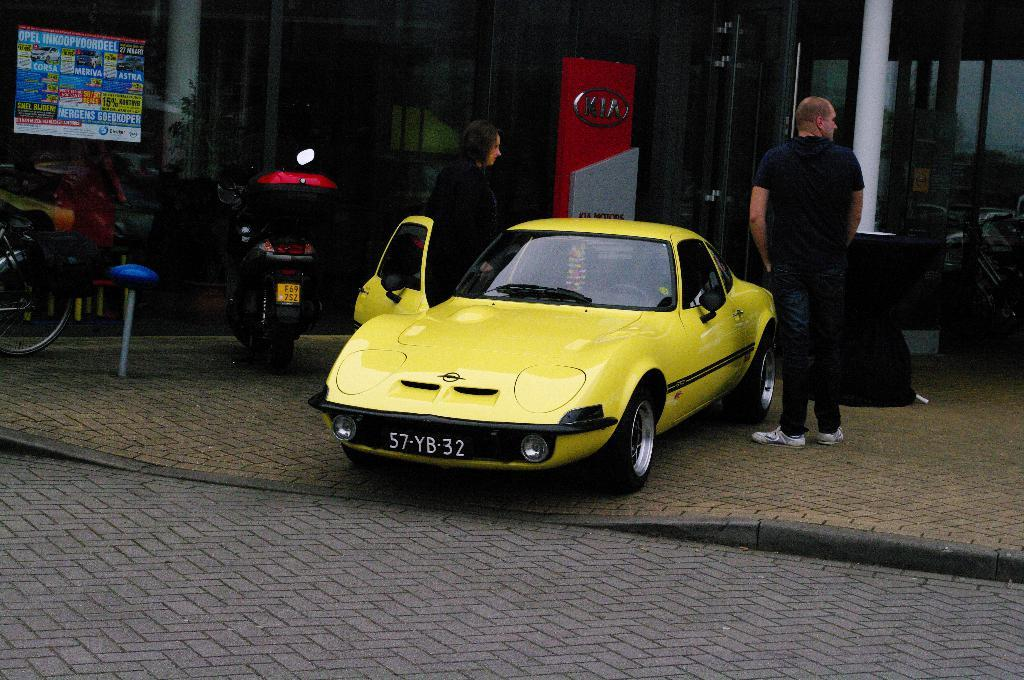<image>
Write a terse but informative summary of the picture. A yellow sports car with a tag that reads 57-YB-32. 